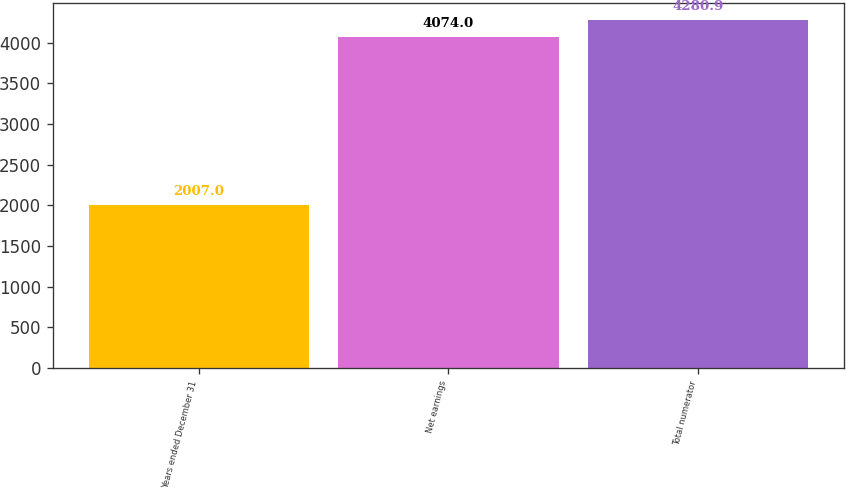Convert chart to OTSL. <chart><loc_0><loc_0><loc_500><loc_500><bar_chart><fcel>Years ended December 31<fcel>Net earnings<fcel>Total numerator<nl><fcel>2007<fcel>4074<fcel>4280.9<nl></chart> 